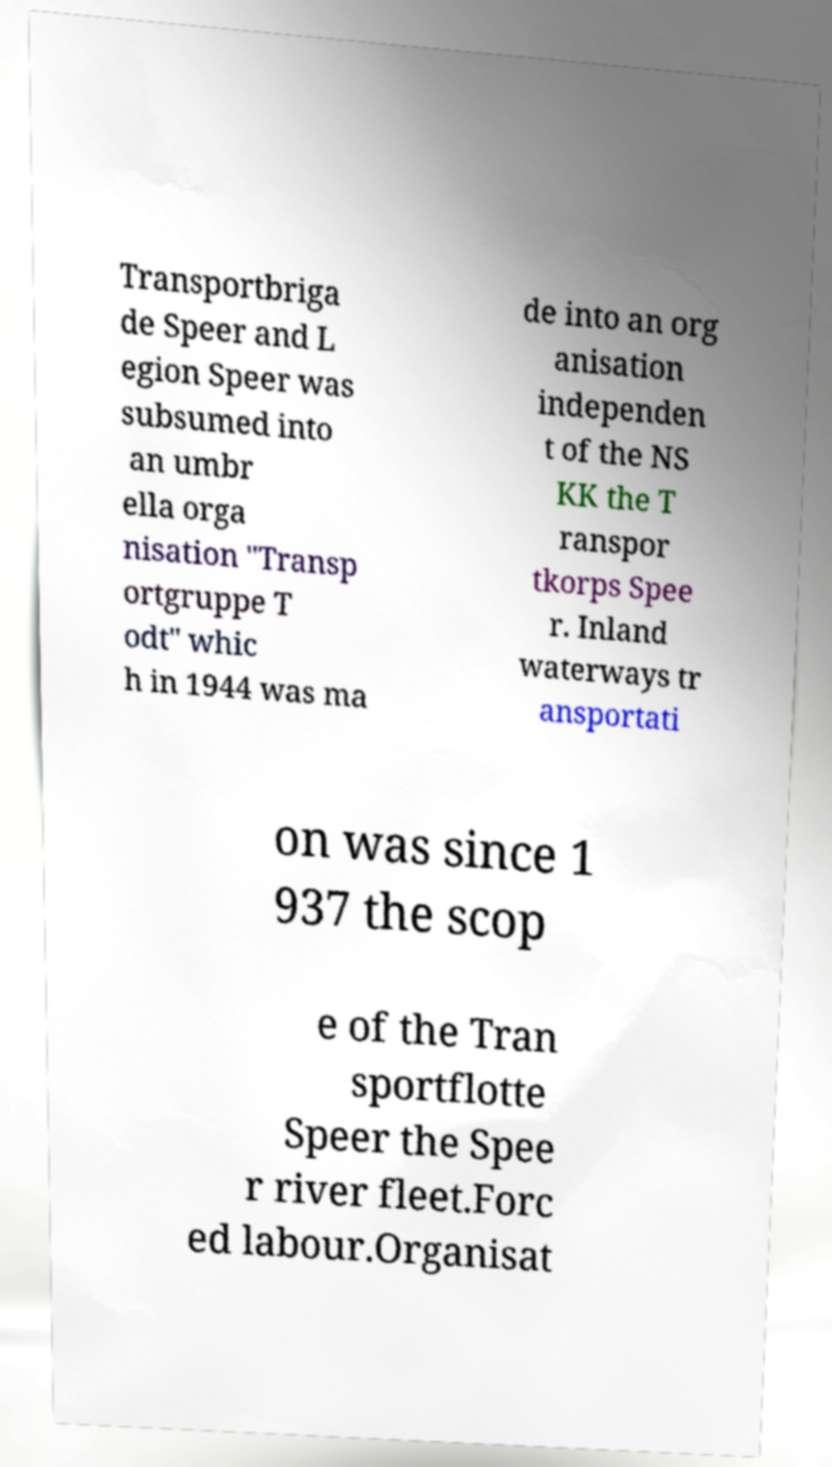Could you assist in decoding the text presented in this image and type it out clearly? Transportbriga de Speer and L egion Speer was subsumed into an umbr ella orga nisation "Transp ortgruppe T odt" whic h in 1944 was ma de into an org anisation independen t of the NS KK the T ranspor tkorps Spee r. Inland waterways tr ansportati on was since 1 937 the scop e of the Tran sportflotte Speer the Spee r river fleet.Forc ed labour.Organisat 